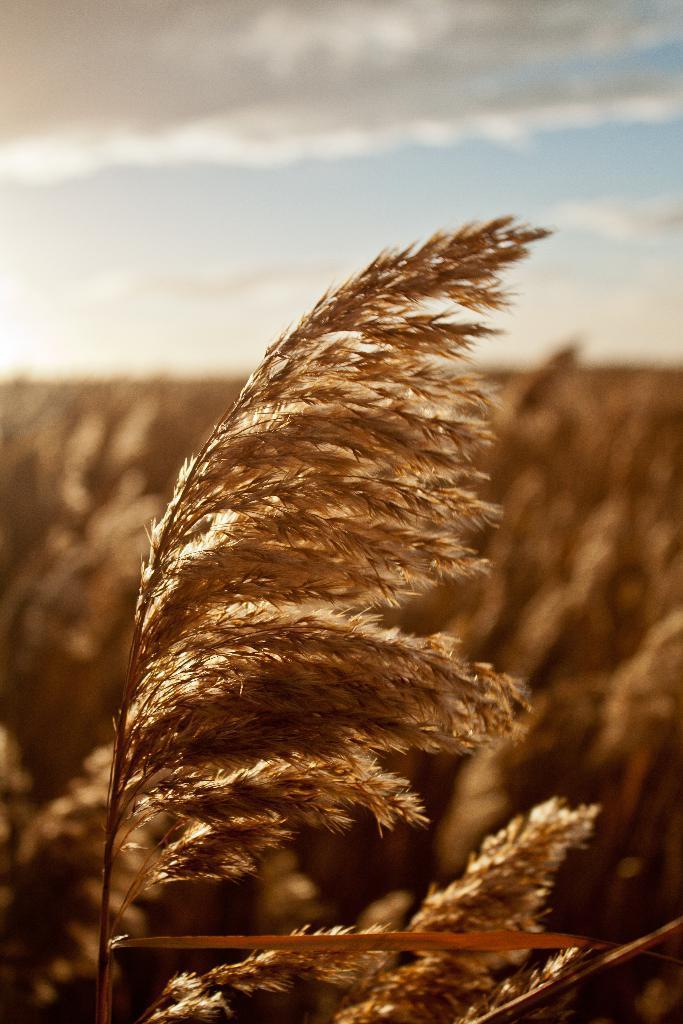Please provide a concise description of this image. In this image we can see a plant and there are few plants and the sky with clouds in the background. 